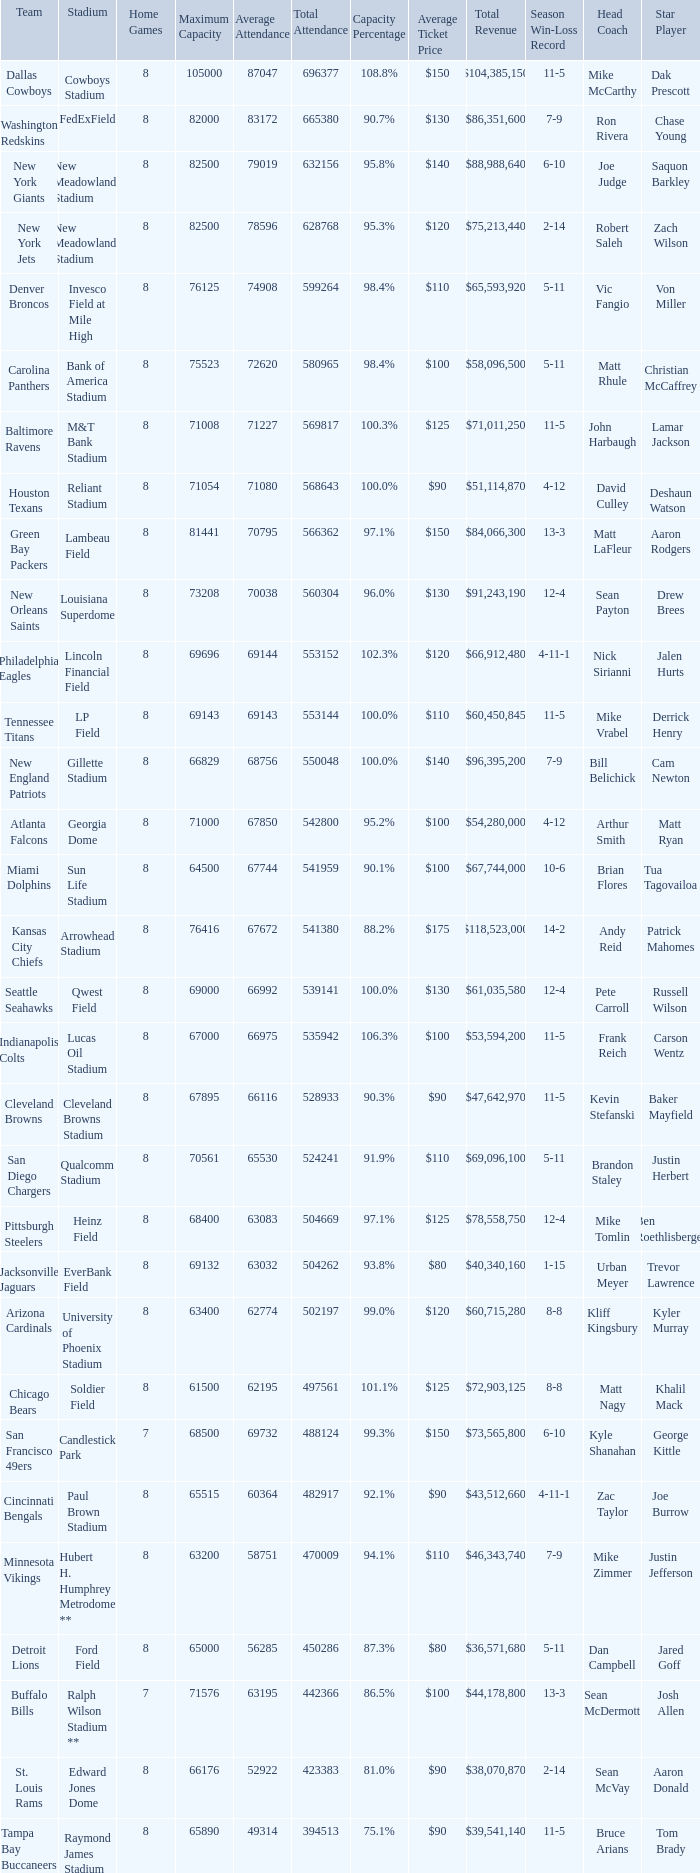What team had a capacity of 102.3%? Philadelphia Eagles. 